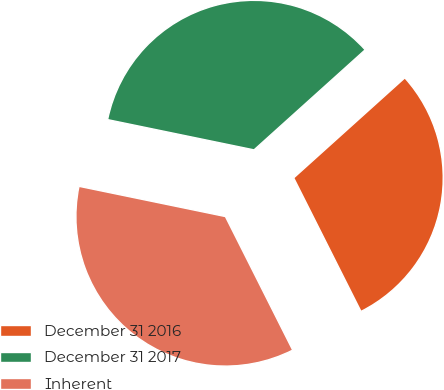Convert chart. <chart><loc_0><loc_0><loc_500><loc_500><pie_chart><fcel>December 31 2016<fcel>December 31 2017<fcel>Inherent<nl><fcel>29.24%<fcel>35.09%<fcel>35.67%<nl></chart> 